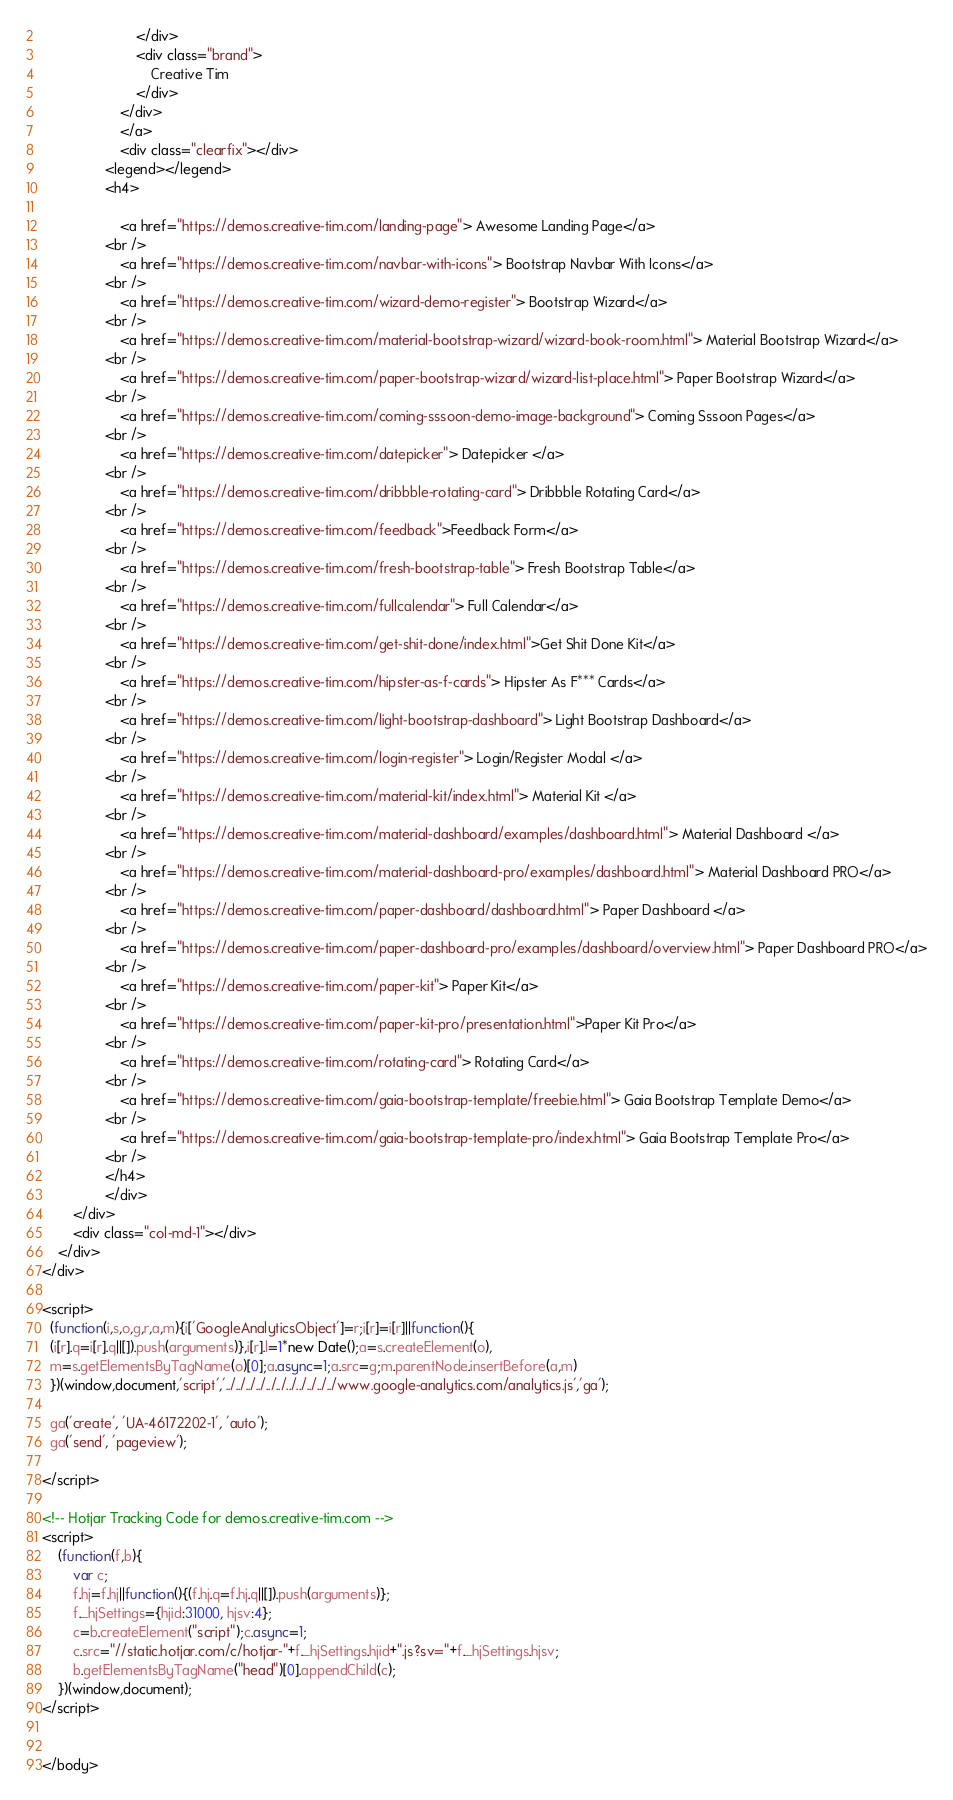<code> <loc_0><loc_0><loc_500><loc_500><_HTML_>                        </div>
                        <div class="brand">
                            Creative Tim
                        </div>
                    </div>
                    </a>
                    <div class="clearfix"></div>
                <legend></legend>
                <h4>

                    <a href="https://demos.creative-tim.com/landing-page"> Awesome Landing Page</a>
                <br />
                    <a href="https://demos.creative-tim.com/navbar-with-icons"> Bootstrap Navbar With Icons</a>
                <br />
                    <a href="https://demos.creative-tim.com/wizard-demo-register"> Bootstrap Wizard</a>
                <br />
					<a href="https://demos.creative-tim.com/material-bootstrap-wizard/wizard-book-room.html"> Material Bootstrap Wizard</a>
				<br />
					<a href="https://demos.creative-tim.com/paper-bootstrap-wizard/wizard-list-place.html"> Paper Bootstrap Wizard</a>
				<br />
                    <a href="https://demos.creative-tim.com/coming-sssoon-demo-image-background"> Coming Sssoon Pages</a>
                <br />
                    <a href="https://demos.creative-tim.com/datepicker"> Datepicker </a>
                <br />
                    <a href="https://demos.creative-tim.com/dribbble-rotating-card"> Dribbble Rotating Card</a>
                <br />
                    <a href="https://demos.creative-tim.com/feedback">Feedback Form</a>
                <br />
                    <a href="https://demos.creative-tim.com/fresh-bootstrap-table"> Fresh Bootstrap Table</a>
                <br />
                    <a href="https://demos.creative-tim.com/fullcalendar"> Full Calendar</a>
                <br />
                    <a href="https://demos.creative-tim.com/get-shit-done/index.html">Get Shit Done Kit</a>
                <br />
                    <a href="https://demos.creative-tim.com/hipster-as-f-cards"> Hipster As F*** Cards</a>
                <br />
                    <a href="https://demos.creative-tim.com/light-bootstrap-dashboard"> Light Bootstrap Dashboard</a>
                <br />
                    <a href="https://demos.creative-tim.com/login-register"> Login/Register Modal </a>
                <br />
                    <a href="https://demos.creative-tim.com/material-kit/index.html"> Material Kit </a>
				<br />
					<a href="https://demos.creative-tim.com/material-dashboard/examples/dashboard.html"> Material Dashboard </a>
				<br />
					<a href="https://demos.creative-tim.com/material-dashboard-pro/examples/dashboard.html"> Material Dashboard PRO</a>
				<br />
                    <a href="https://demos.creative-tim.com/paper-dashboard/dashboard.html"> Paper Dashboard </a>
				<br />
				    <a href="https://demos.creative-tim.com/paper-dashboard-pro/examples/dashboard/overview.html"> Paper Dashboard PRO</a>
				<br />
                    <a href="https://demos.creative-tim.com/paper-kit"> Paper Kit</a>
				<br />
                    <a href="https://demos.creative-tim.com/paper-kit-pro/presentation.html">Paper Kit Pro</a>
                <br />
                    <a href="https://demos.creative-tim.com/rotating-card"> Rotating Card</a>
				<br />
					<a href="https://demos.creative-tim.com/gaia-bootstrap-template/freebie.html"> Gaia Bootstrap Template Demo</a>
                <br />
					<a href="https://demos.creative-tim.com/gaia-bootstrap-template-pro/index.html"> Gaia Bootstrap Template Pro</a>
				<br />
                </h4>
                </div>
        </div>
        <div class="col-md-1"></div>
    </div>
</div>

<script>
  (function(i,s,o,g,r,a,m){i['GoogleAnalyticsObject']=r;i[r]=i[r]||function(){
  (i[r].q=i[r].q||[]).push(arguments)},i[r].l=1*new Date();a=s.createElement(o),
  m=s.getElementsByTagName(o)[0];a.async=1;a.src=g;m.parentNode.insertBefore(a,m)
  })(window,document,'script','../../../../../../../../../../../www.google-analytics.com/analytics.js','ga');

  ga('create', 'UA-46172202-1', 'auto');
  ga('send', 'pageview');

</script>

<!-- Hotjar Tracking Code for demos.creative-tim.com -->
<script>
    (function(f,b){
        var c;
        f.hj=f.hj||function(){(f.hj.q=f.hj.q||[]).push(arguments)};
        f._hjSettings={hjid:31000, hjsv:4};
        c=b.createElement("script");c.async=1;
        c.src="//static.hotjar.com/c/hotjar-"+f._hjSettings.hjid+".js?sv="+f._hjSettings.hjsv;
        b.getElementsByTagName("head")[0].appendChild(c);
    })(window,document);
</script>


</body>
</code> 